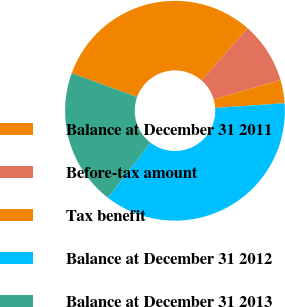<chart> <loc_0><loc_0><loc_500><loc_500><pie_chart><fcel>Balance at December 31 2011<fcel>Before-tax amount<fcel>Tax benefit<fcel>Balance at December 31 2012<fcel>Balance at December 31 2013<nl><fcel>30.96%<fcel>8.99%<fcel>3.42%<fcel>36.53%<fcel>20.1%<nl></chart> 